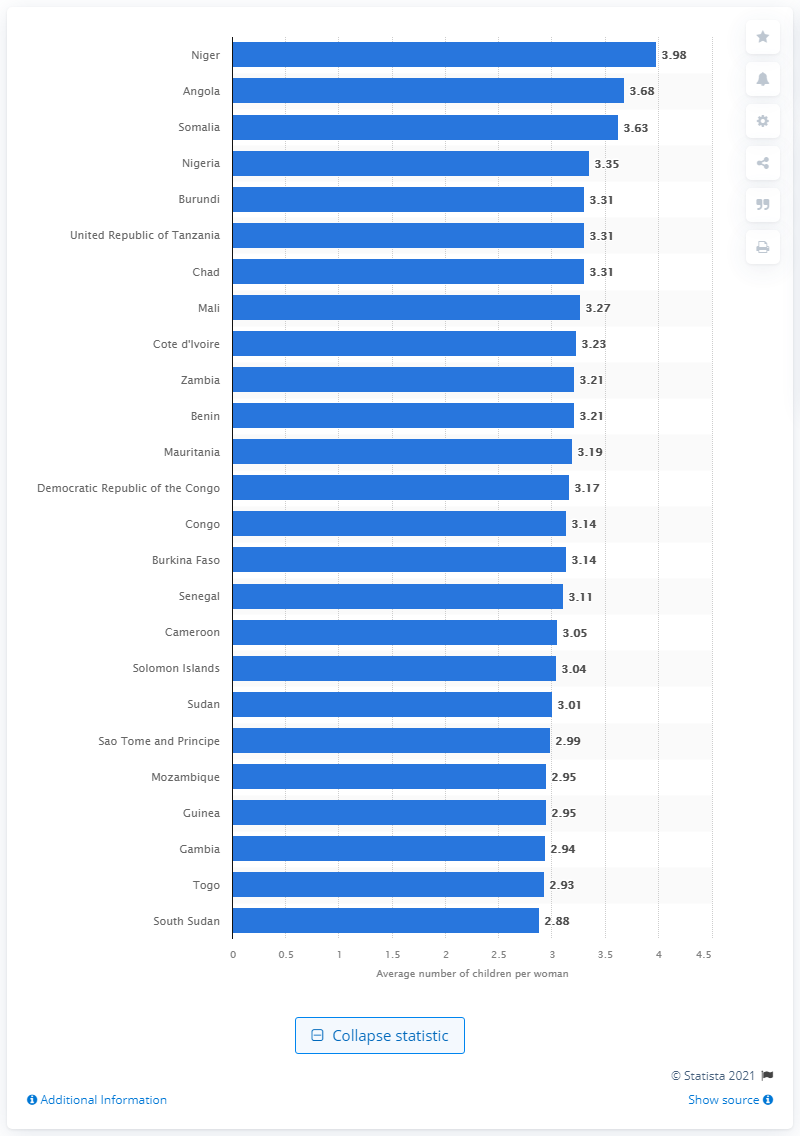Draw attention to some important aspects in this diagram. The average fertility rate in Niger is expected to be 3.98 between 2050 and 2055, according to projections. 